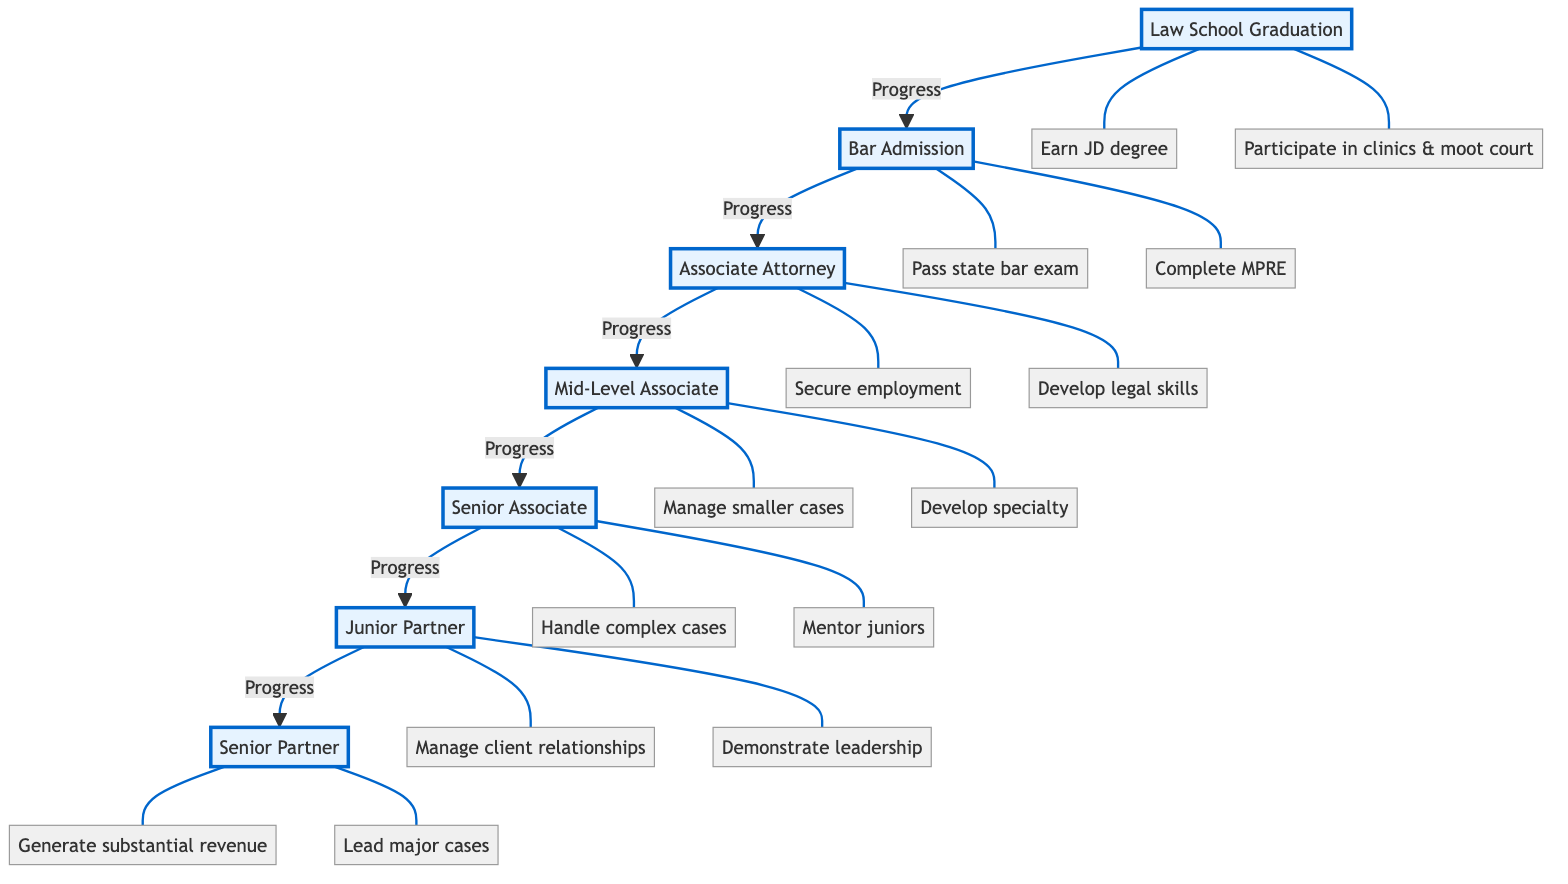What is the initial stage of the career advancement path? The career advancement path starts with "Law School Graduation," which is the foundational step for entering the legal profession.
Answer: Law School Graduation How many stages are there from Bar Admission to Senior Partner? Counting the stages from Bar Admission to Senior Partner includes Bar Admission, Associate Attorney, Mid-Level Associate, Senior Associate, Junior Partner, and Senior Partner, totaling six stages.
Answer: Six What achievement is directly associated with Bar Admission? The primary achievements related to Bar Admission include passing the state bar exam and completing the Multistate Professional Responsibility Examination, with "Pass the state bar exam" being one of the key achievements.
Answer: Pass the state bar exam At which stage do attorneys begin managing client relationships? Attorneys start managing significant client relationships at the Junior Partner stage, indicating a step towards greater responsibility and influence within the firm.
Answer: Junior Partner What do Senior Associates do concerning junior colleagues? Senior Associates are responsible for mentoring junior associates and paralegals, aiding their professional development and ensuring knowledge transfer within the firm.
Answer: Mentor junior associates and paralegals What achievement indicates a transition from Mid-Level Associate to Senior Associate? The transition to Senior Associate is marked by the ability to take on more complex cases with minimal supervision, demonstrating increased competence and reliance in legal practice.
Answer: Take on more complex cases Which stage is responsible for leading major litigation or transactional cases? The stage where attorneys lead major litigation or transactional cases is the Senior Partner stage, reflecting a high level of expertise and leadership in legal matters.
Answer: Senior Partner What is the final achievement listed for Senior Partners? The final achievement for Senior Partners is to mentor upcoming junior partners and associates, indicating their role in shaping the future of the firm and its talents.
Answer: Mentor upcoming junior partners Which achievement involves developing a specialty in a specific area? The achievement that involves developing a niche or specialty in a specific area of law is associated with the Mid-Level Associate stage, highlighting a focused career path.
Answer: Develop a niche or specialty 